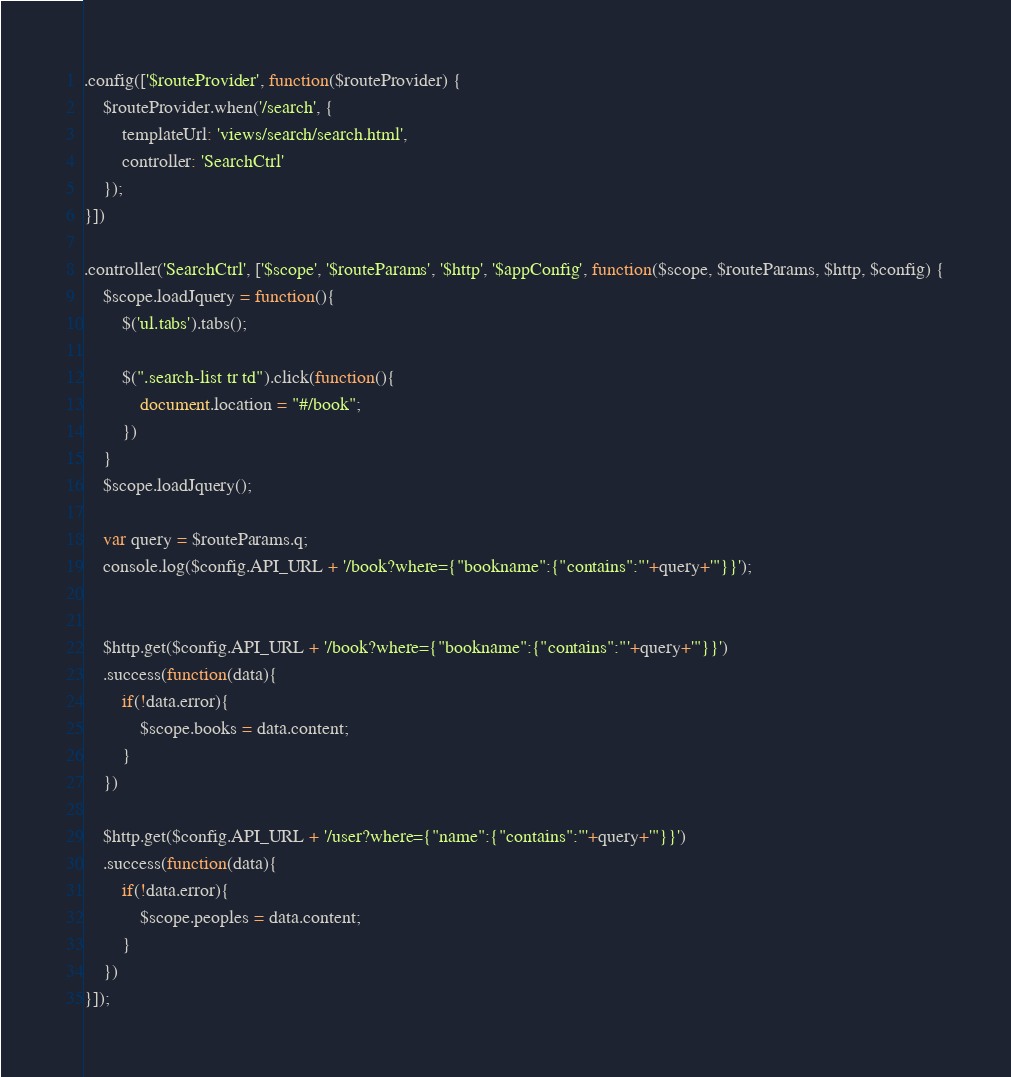<code> <loc_0><loc_0><loc_500><loc_500><_JavaScript_>
.config(['$routeProvider', function($routeProvider) {
	$routeProvider.when('/search', {
		templateUrl: 'views/search/search.html',
		controller: 'SearchCtrl'
	});
}])

.controller('SearchCtrl', ['$scope', '$routeParams', '$http', '$appConfig', function($scope, $routeParams, $http, $config) {
	$scope.loadJquery = function(){
		$('ul.tabs').tabs();

		$(".search-list tr td").click(function(){
			document.location = "#/book";
		})
	}
	$scope.loadJquery();

	var query = $routeParams.q;
	console.log($config.API_URL + '/book?where={"bookname":{"contains":"'+query+'"}}');


	$http.get($config.API_URL + '/book?where={"bookname":{"contains":"'+query+'"}}')
	.success(function(data){
		if(!data.error){
			$scope.books = data.content;
		}
	})

	$http.get($config.API_URL + '/user?where={"name":{"contains":"'+query+'"}}')
	.success(function(data){
		if(!data.error){
			$scope.peoples = data.content;
		}
	})
}]);</code> 